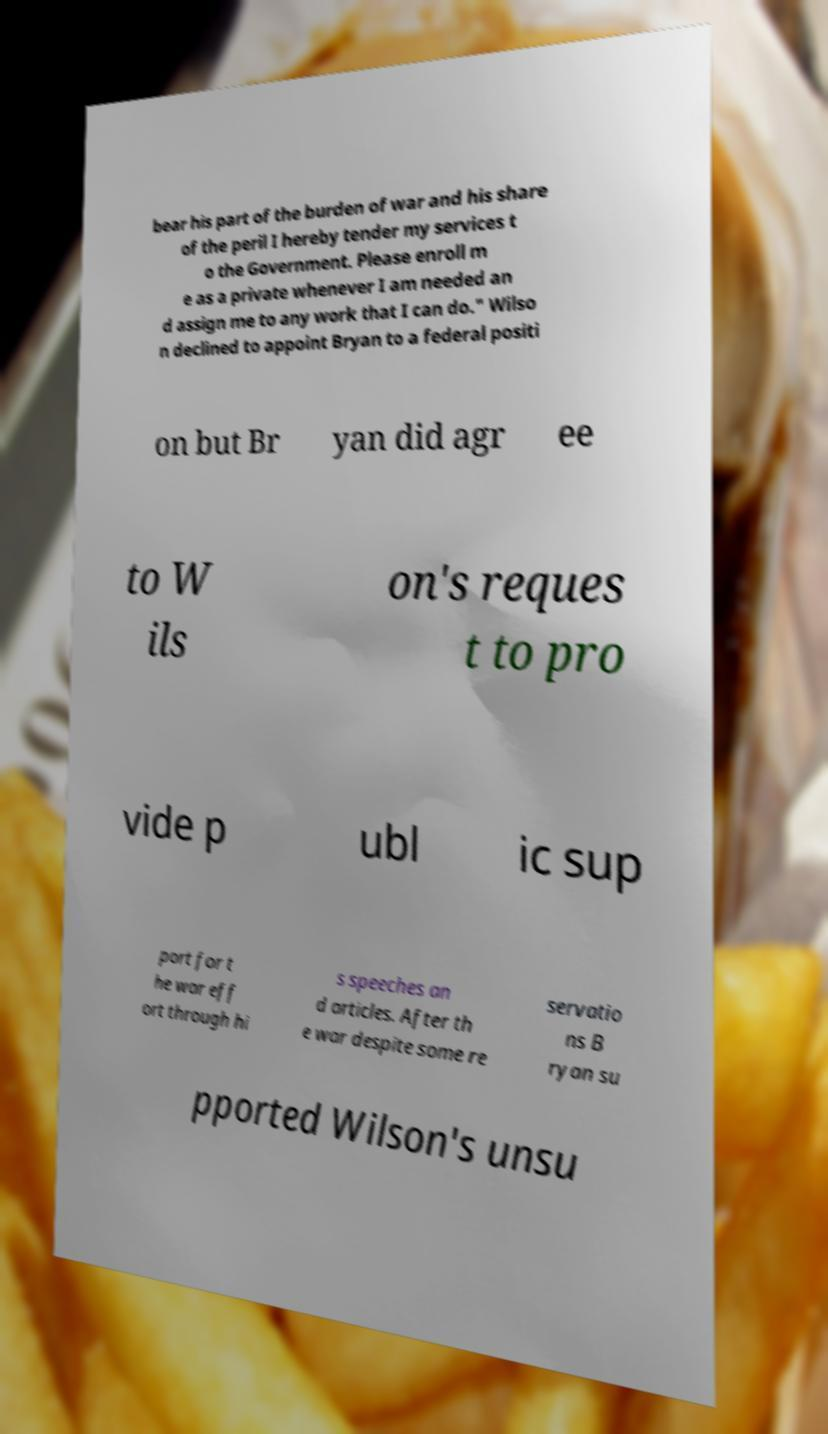Please identify and transcribe the text found in this image. bear his part of the burden of war and his share of the peril I hereby tender my services t o the Government. Please enroll m e as a private whenever I am needed an d assign me to any work that I can do." Wilso n declined to appoint Bryan to a federal positi on but Br yan did agr ee to W ils on's reques t to pro vide p ubl ic sup port for t he war eff ort through hi s speeches an d articles. After th e war despite some re servatio ns B ryan su pported Wilson's unsu 